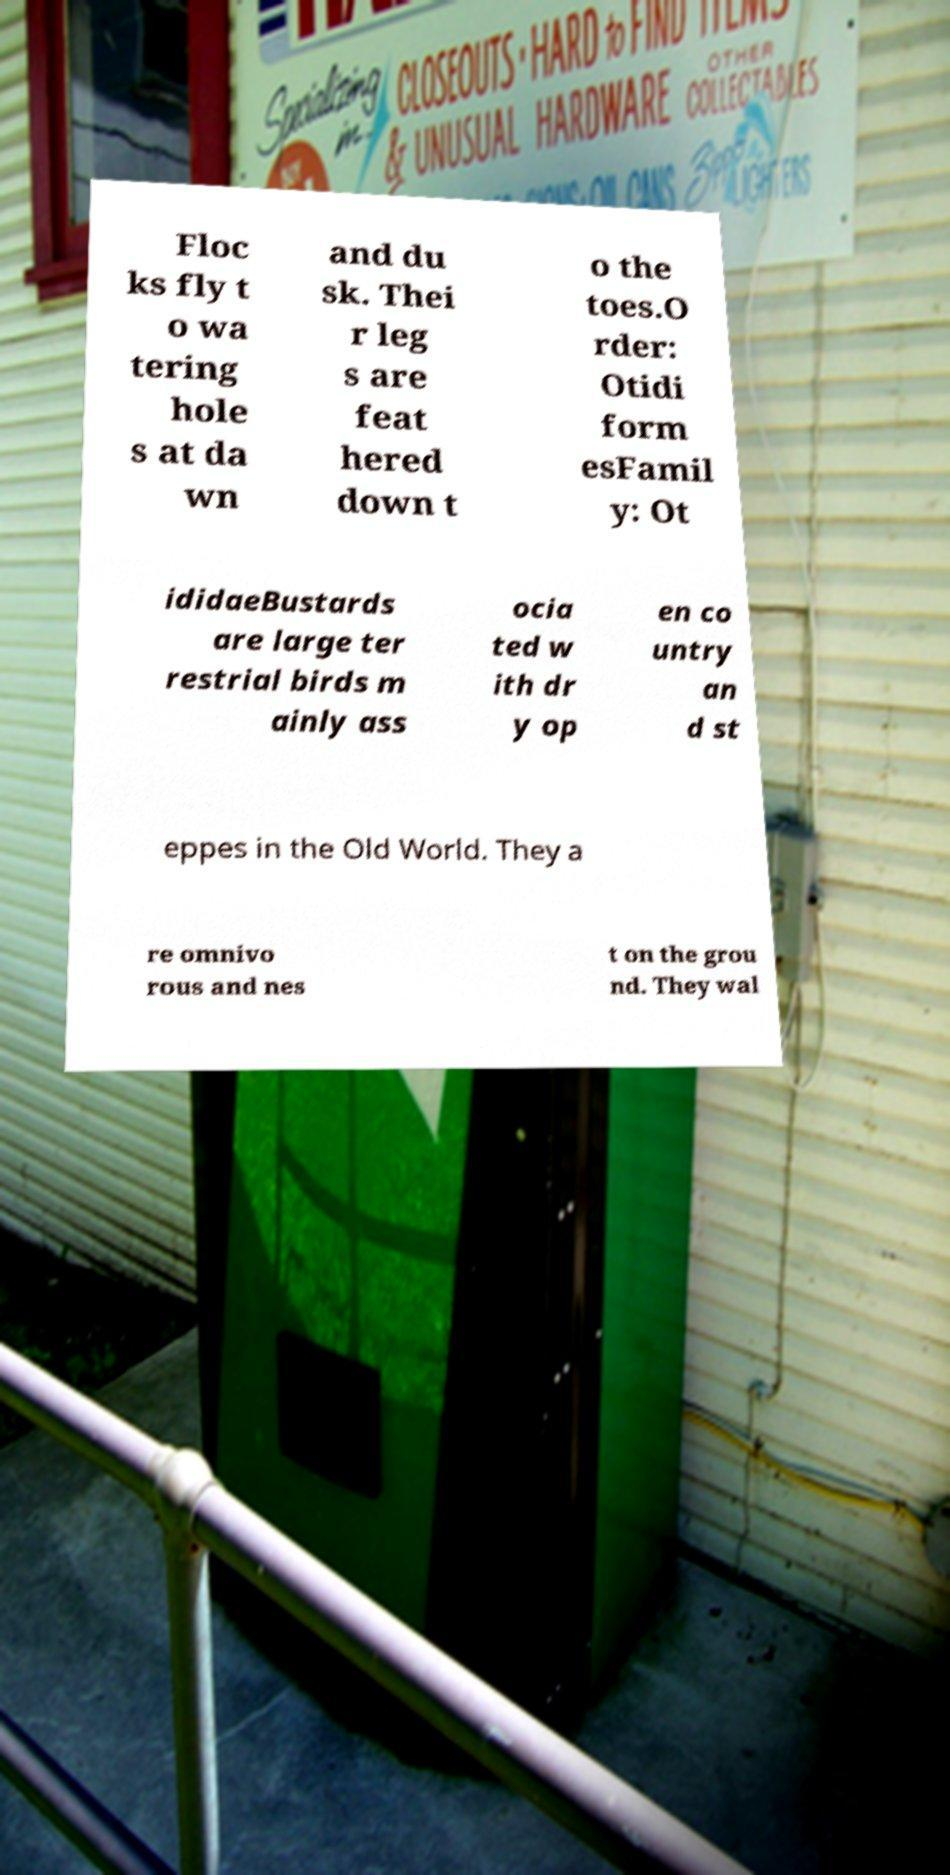Could you extract and type out the text from this image? Floc ks fly t o wa tering hole s at da wn and du sk. Thei r leg s are feat hered down t o the toes.O rder: Otidi form esFamil y: Ot ididaeBustards are large ter restrial birds m ainly ass ocia ted w ith dr y op en co untry an d st eppes in the Old World. They a re omnivo rous and nes t on the grou nd. They wal 